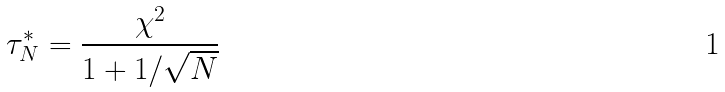<formula> <loc_0><loc_0><loc_500><loc_500>\tau _ { N } ^ { * } = \frac { \chi ^ { 2 } } { 1 + 1 / \sqrt { N } }</formula> 